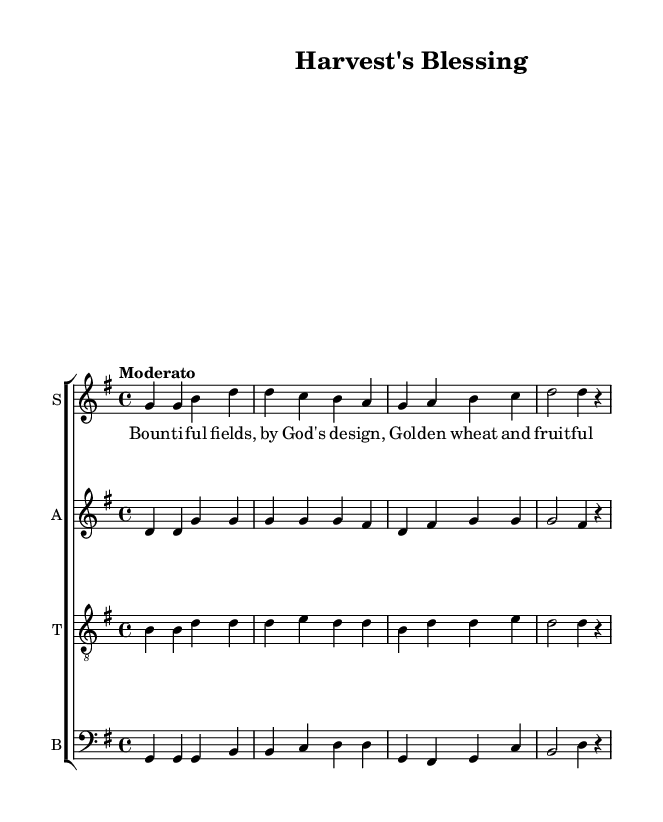What is the key signature of this music? The key signature can be identified by looking at the beginning of the music staff where the sharps or flats are indicated. Here, there are no sharps or flats shown, indicating that it is in G major which has one sharp (F#).
Answer: G major What is the time signature of this music? The time signature is indicated by the fraction at the beginning of the score, which shows the number of beats in each measure. Here, it is marked 4/4, meaning there are four beats per measure.
Answer: 4/4 What is the tempo marking for this music? The tempo marking is often placed above the staff at the beginning. In this score, it indicates "Moderato," which suggests a moderate speed for the performance.
Answer: Moderato How many vocal parts are there in this hymn? By examining the score, we can see there are four staves labeled as Soprano, Alto, Tenor, and Bass, each representing a vocal part. Thus, there are four parts in total.
Answer: Four What is the main theme depicted in the lyrics of this hymn? The lyrics reveal agricultural imagery with words like "fields," "wheat," and "vine." This suggests a focus on nature and divine blessings related to harvest and agricultural life.
Answer: Agricultural life In which mode is this hymn composed? To determine the mode, we refer to the key signature and the overall sound. Since it has a major key signature, we conclude that it is in a major mode typical for hymns conveying positive themes.
Answer: Major What is the lyrical content's relevance to divine providence? The lyrics express gratitude for bountiful harvests, directly linking agricultural success with divine will, reflecting a common theme in medieval hymns that attribute farming prosperity to divine favor.
Answer: Divine favor 